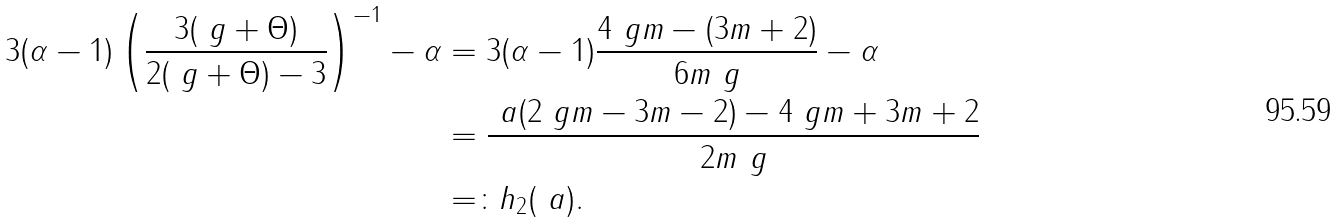Convert formula to latex. <formula><loc_0><loc_0><loc_500><loc_500>3 ( \alpha - 1 ) \left ( \frac { 3 ( \ g + \Theta ) } { 2 ( \ g + \Theta ) - 3 } \right ) ^ { - 1 } - \alpha & = 3 ( \alpha - 1 ) \frac { 4 \ g m - ( 3 m + 2 ) } { 6 m \ g } - \alpha \\ & = \frac { \ a ( 2 \ g m - 3 m - 2 ) - 4 \ g m + 3 m + 2 } { 2 m \ g } \\ & = \colon h _ { 2 } ( \ a ) .</formula> 